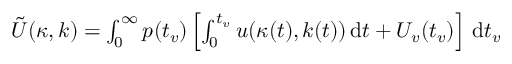Convert formula to latex. <formula><loc_0><loc_0><loc_500><loc_500>\begin{array} { r } { \tilde { U } ( \kappa , k ) = \int _ { 0 } ^ { \infty } p ( t _ { v } ) \left [ \int _ { 0 } ^ { t _ { v } } u ( \kappa ( t ) , k ( t ) ) \, d t + U _ { v } ( t _ { v } ) \right ] \, d t _ { v } } \end{array}</formula> 